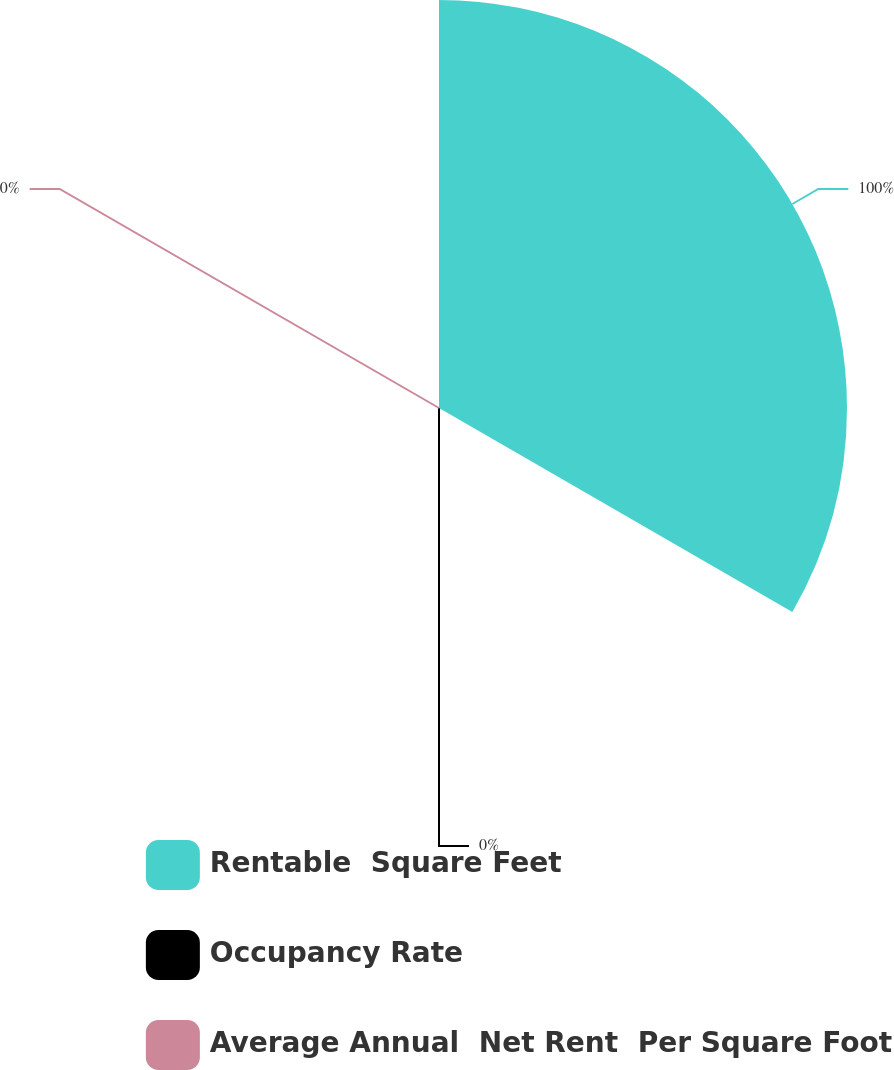Convert chart to OTSL. <chart><loc_0><loc_0><loc_500><loc_500><pie_chart><fcel>Rentable  Square Feet<fcel>Occupancy Rate<fcel>Average Annual  Net Rent  Per Square Foot<nl><fcel>100.0%<fcel>0.0%<fcel>0.0%<nl></chart> 